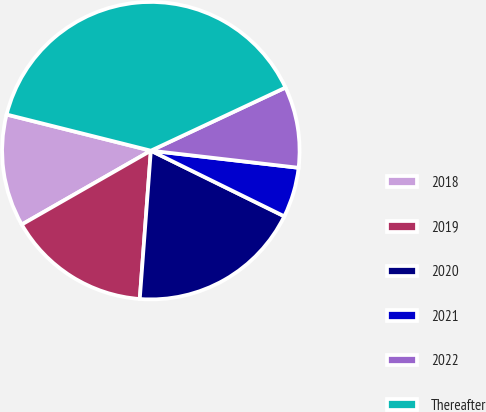<chart> <loc_0><loc_0><loc_500><loc_500><pie_chart><fcel>2018<fcel>2019<fcel>2020<fcel>2021<fcel>2022<fcel>Thereafter<nl><fcel>12.18%<fcel>15.54%<fcel>18.91%<fcel>5.44%<fcel>8.81%<fcel>39.11%<nl></chart> 